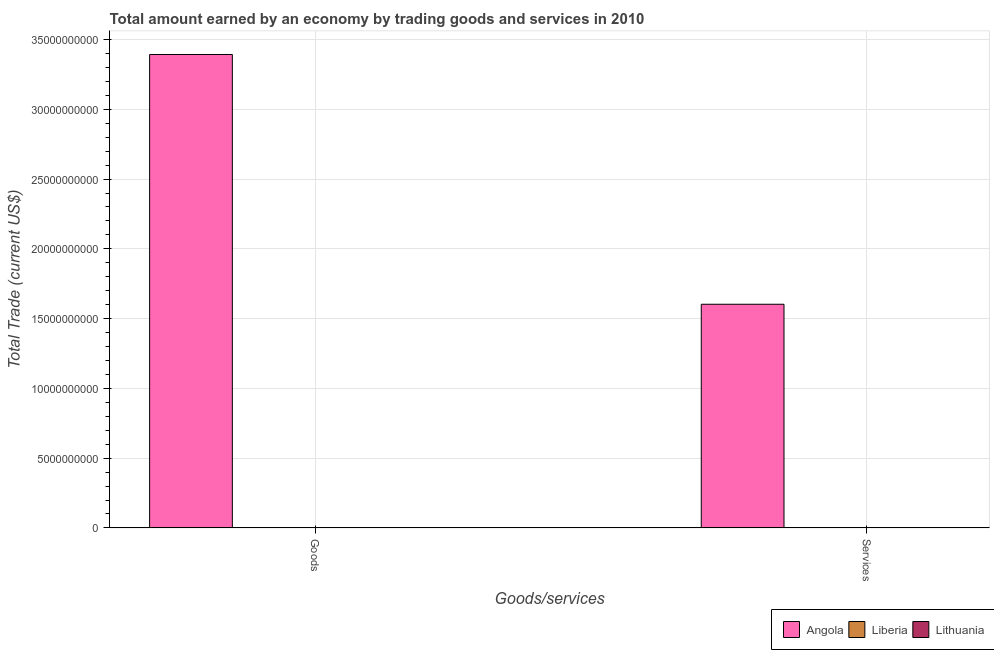How many bars are there on the 1st tick from the right?
Make the answer very short. 1. What is the label of the 1st group of bars from the left?
Your answer should be very brief. Goods. What is the amount earned by trading goods in Angola?
Offer a terse response. 3.39e+1. Across all countries, what is the maximum amount earned by trading goods?
Provide a short and direct response. 3.39e+1. In which country was the amount earned by trading goods maximum?
Offer a terse response. Angola. What is the total amount earned by trading services in the graph?
Your answer should be very brief. 1.60e+1. What is the difference between the amount earned by trading services in Liberia and the amount earned by trading goods in Angola?
Make the answer very short. -3.39e+1. What is the average amount earned by trading services per country?
Offer a very short reply. 5.34e+09. What is the difference between the amount earned by trading services and amount earned by trading goods in Angola?
Your answer should be compact. -1.79e+1. In how many countries, is the amount earned by trading services greater than 2000000000 US$?
Give a very brief answer. 1. In how many countries, is the amount earned by trading services greater than the average amount earned by trading services taken over all countries?
Provide a short and direct response. 1. How many bars are there?
Make the answer very short. 2. Are all the bars in the graph horizontal?
Make the answer very short. No. What is the difference between two consecutive major ticks on the Y-axis?
Give a very brief answer. 5.00e+09. Does the graph contain any zero values?
Give a very brief answer. Yes. Where does the legend appear in the graph?
Ensure brevity in your answer.  Bottom right. How are the legend labels stacked?
Your response must be concise. Horizontal. What is the title of the graph?
Provide a succinct answer. Total amount earned by an economy by trading goods and services in 2010. What is the label or title of the X-axis?
Provide a succinct answer. Goods/services. What is the label or title of the Y-axis?
Provide a short and direct response. Total Trade (current US$). What is the Total Trade (current US$) in Angola in Goods?
Give a very brief answer. 3.39e+1. What is the Total Trade (current US$) in Liberia in Goods?
Offer a terse response. 0. What is the Total Trade (current US$) in Angola in Services?
Give a very brief answer. 1.60e+1. What is the Total Trade (current US$) of Liberia in Services?
Keep it short and to the point. 0. Across all Goods/services, what is the maximum Total Trade (current US$) of Angola?
Provide a short and direct response. 3.39e+1. Across all Goods/services, what is the minimum Total Trade (current US$) of Angola?
Ensure brevity in your answer.  1.60e+1. What is the total Total Trade (current US$) in Angola in the graph?
Your answer should be very brief. 5.00e+1. What is the total Total Trade (current US$) in Lithuania in the graph?
Give a very brief answer. 0. What is the difference between the Total Trade (current US$) of Angola in Goods and that in Services?
Provide a succinct answer. 1.79e+1. What is the average Total Trade (current US$) of Angola per Goods/services?
Your answer should be very brief. 2.50e+1. What is the average Total Trade (current US$) of Liberia per Goods/services?
Make the answer very short. 0. What is the average Total Trade (current US$) in Lithuania per Goods/services?
Provide a succinct answer. 0. What is the ratio of the Total Trade (current US$) in Angola in Goods to that in Services?
Keep it short and to the point. 2.12. What is the difference between the highest and the second highest Total Trade (current US$) of Angola?
Your answer should be compact. 1.79e+1. What is the difference between the highest and the lowest Total Trade (current US$) in Angola?
Your answer should be very brief. 1.79e+1. 